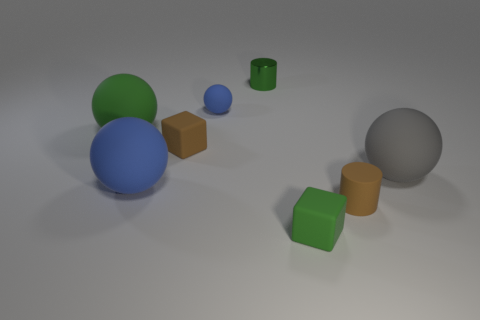Are there any other things that have the same material as the green cylinder?
Provide a short and direct response. No. There is a green object that is the same material as the big green sphere; what is its shape?
Keep it short and to the point. Cube. Is the number of big green objects that are in front of the small brown cylinder less than the number of small red cubes?
Offer a very short reply. No. Is the large green matte object the same shape as the large gray matte object?
Your answer should be very brief. Yes. What number of matte objects are either big blue cylinders or small green blocks?
Your answer should be very brief. 1. Is there a green object of the same size as the metal cylinder?
Offer a terse response. Yes. There is a small matte object that is the same color as the metal cylinder; what shape is it?
Provide a short and direct response. Cube. How many other matte objects are the same size as the gray object?
Make the answer very short. 2. Is the size of the green thing that is in front of the big green ball the same as the metal thing behind the gray sphere?
Your answer should be very brief. Yes. How many things are gray spheres or matte balls behind the large gray object?
Offer a very short reply. 3. 